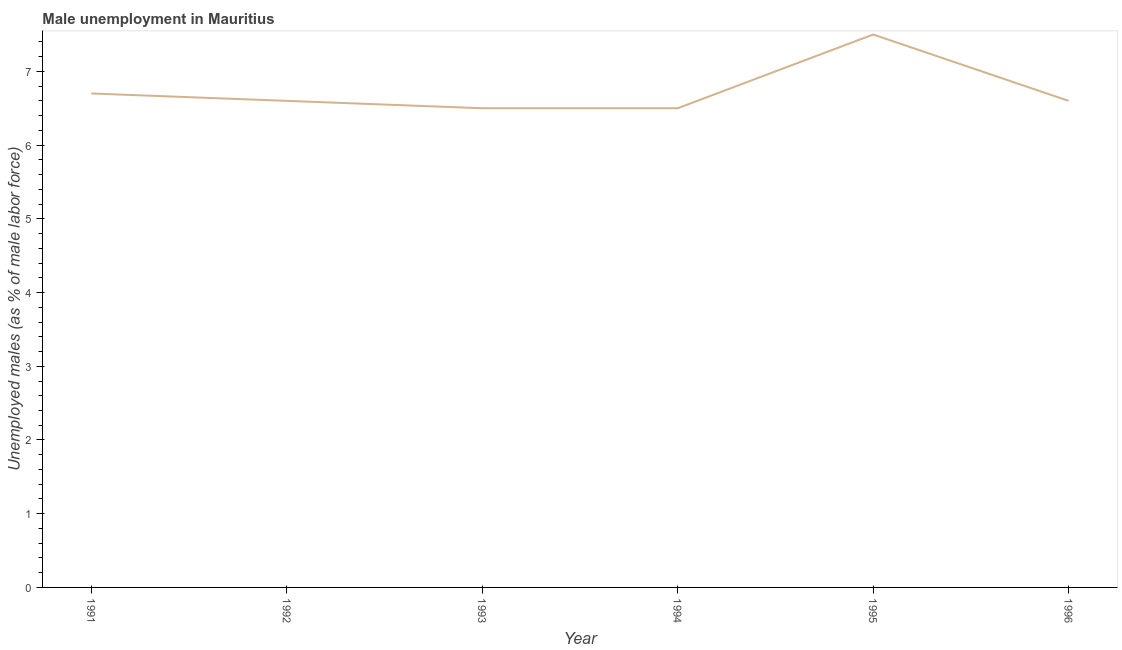What is the unemployed males population in 1992?
Offer a terse response. 6.6. Across all years, what is the maximum unemployed males population?
Offer a terse response. 7.5. Across all years, what is the minimum unemployed males population?
Give a very brief answer. 6.5. What is the sum of the unemployed males population?
Provide a short and direct response. 40.4. What is the difference between the unemployed males population in 1992 and 1995?
Give a very brief answer. -0.9. What is the average unemployed males population per year?
Your answer should be very brief. 6.73. What is the median unemployed males population?
Give a very brief answer. 6.6. Do a majority of the years between 1995 and 1991 (inclusive) have unemployed males population greater than 7 %?
Offer a very short reply. Yes. What is the ratio of the unemployed males population in 1991 to that in 1996?
Offer a terse response. 1.02. What is the difference between the highest and the second highest unemployed males population?
Provide a short and direct response. 0.8. What is the difference between the highest and the lowest unemployed males population?
Your answer should be compact. 1. Does the unemployed males population monotonically increase over the years?
Provide a short and direct response. No. How many years are there in the graph?
Provide a short and direct response. 6. Does the graph contain any zero values?
Give a very brief answer. No. Does the graph contain grids?
Make the answer very short. No. What is the title of the graph?
Your answer should be very brief. Male unemployment in Mauritius. What is the label or title of the X-axis?
Offer a very short reply. Year. What is the label or title of the Y-axis?
Give a very brief answer. Unemployed males (as % of male labor force). What is the Unemployed males (as % of male labor force) in 1991?
Provide a short and direct response. 6.7. What is the Unemployed males (as % of male labor force) of 1992?
Offer a terse response. 6.6. What is the Unemployed males (as % of male labor force) in 1996?
Make the answer very short. 6.6. What is the difference between the Unemployed males (as % of male labor force) in 1991 and 1992?
Provide a short and direct response. 0.1. What is the difference between the Unemployed males (as % of male labor force) in 1991 and 1993?
Keep it short and to the point. 0.2. What is the difference between the Unemployed males (as % of male labor force) in 1991 and 1994?
Your answer should be very brief. 0.2. What is the difference between the Unemployed males (as % of male labor force) in 1991 and 1995?
Offer a terse response. -0.8. What is the difference between the Unemployed males (as % of male labor force) in 1992 and 1993?
Provide a short and direct response. 0.1. What is the difference between the Unemployed males (as % of male labor force) in 1993 and 1994?
Your response must be concise. 0. What is the difference between the Unemployed males (as % of male labor force) in 1993 and 1995?
Ensure brevity in your answer.  -1. What is the difference between the Unemployed males (as % of male labor force) in 1993 and 1996?
Provide a short and direct response. -0.1. What is the difference between the Unemployed males (as % of male labor force) in 1994 and 1995?
Your response must be concise. -1. What is the difference between the Unemployed males (as % of male labor force) in 1994 and 1996?
Your answer should be very brief. -0.1. What is the difference between the Unemployed males (as % of male labor force) in 1995 and 1996?
Make the answer very short. 0.9. What is the ratio of the Unemployed males (as % of male labor force) in 1991 to that in 1992?
Give a very brief answer. 1.01. What is the ratio of the Unemployed males (as % of male labor force) in 1991 to that in 1993?
Give a very brief answer. 1.03. What is the ratio of the Unemployed males (as % of male labor force) in 1991 to that in 1994?
Your response must be concise. 1.03. What is the ratio of the Unemployed males (as % of male labor force) in 1991 to that in 1995?
Your answer should be compact. 0.89. What is the ratio of the Unemployed males (as % of male labor force) in 1992 to that in 1993?
Keep it short and to the point. 1.01. What is the ratio of the Unemployed males (as % of male labor force) in 1992 to that in 1995?
Provide a short and direct response. 0.88. What is the ratio of the Unemployed males (as % of male labor force) in 1993 to that in 1995?
Your answer should be compact. 0.87. What is the ratio of the Unemployed males (as % of male labor force) in 1993 to that in 1996?
Provide a succinct answer. 0.98. What is the ratio of the Unemployed males (as % of male labor force) in 1994 to that in 1995?
Ensure brevity in your answer.  0.87. What is the ratio of the Unemployed males (as % of male labor force) in 1995 to that in 1996?
Your answer should be very brief. 1.14. 